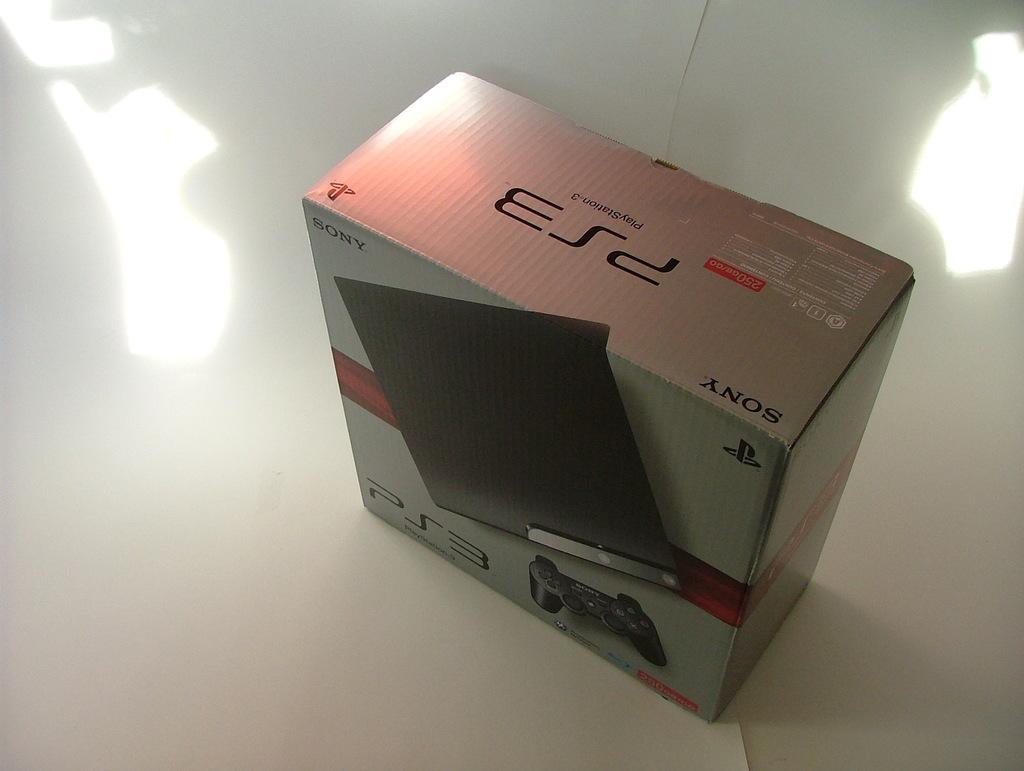What gaming device is this?
Offer a very short reply. Ps3. What is the brand name?
Offer a terse response. Sony. 